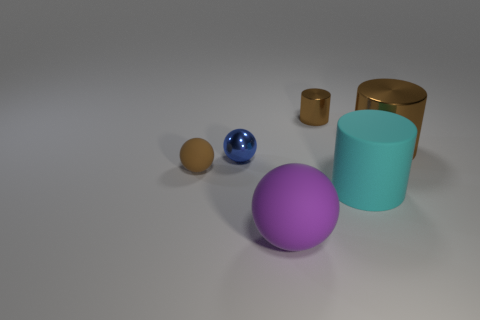Is the number of tiny things less than the number of large rubber objects?
Keep it short and to the point. No. There is a purple thing that is the same size as the cyan thing; what material is it?
Your answer should be very brief. Rubber. Does the sphere that is in front of the tiny brown rubber object have the same size as the brown cylinder behind the big brown cylinder?
Keep it short and to the point. No. Is there a brown sphere made of the same material as the purple object?
Offer a terse response. Yes. How many things are either small metallic things on the right side of the big purple rubber thing or cyan things?
Offer a very short reply. 2. Does the brown cylinder left of the big metal object have the same material as the cyan object?
Keep it short and to the point. No. Does the cyan object have the same shape as the tiny matte thing?
Offer a very short reply. No. There is a tiny brown object that is on the right side of the purple rubber sphere; how many tiny things are left of it?
Provide a succinct answer. 2. What material is the other tiny object that is the same shape as the cyan object?
Provide a short and direct response. Metal. Does the cylinder in front of the tiny brown sphere have the same color as the tiny shiny cylinder?
Keep it short and to the point. No. 